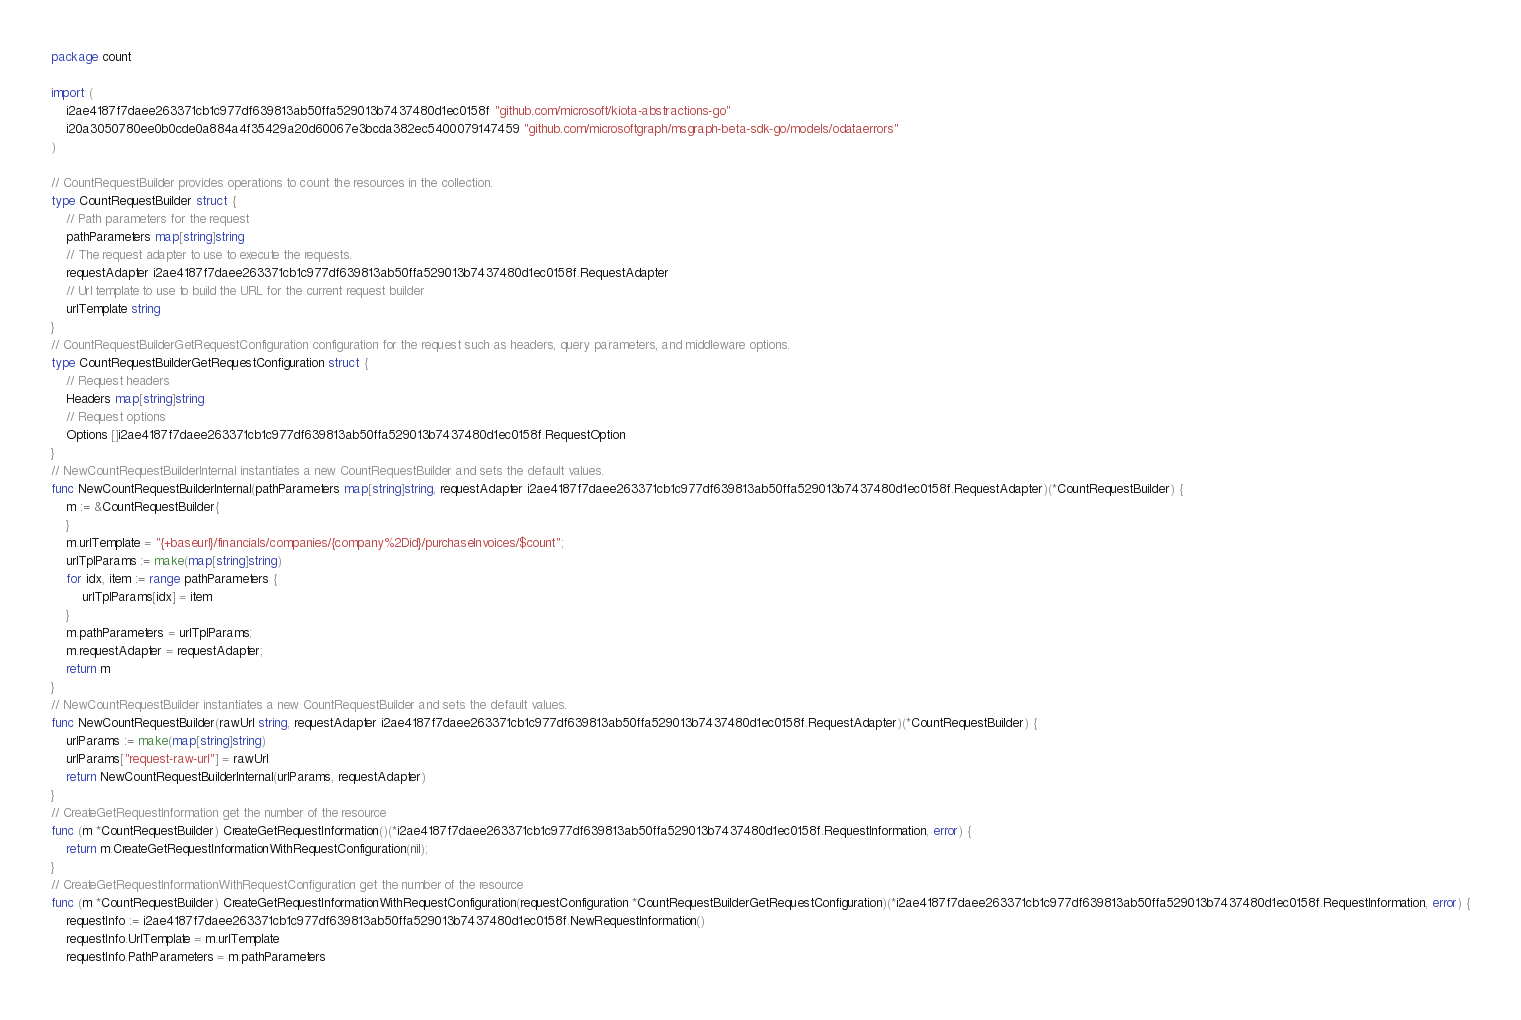<code> <loc_0><loc_0><loc_500><loc_500><_Go_>package count

import (
    i2ae4187f7daee263371cb1c977df639813ab50ffa529013b7437480d1ec0158f "github.com/microsoft/kiota-abstractions-go"
    i20a3050780ee0b0cde0a884a4f35429a20d60067e3bcda382ec5400079147459 "github.com/microsoftgraph/msgraph-beta-sdk-go/models/odataerrors"
)

// CountRequestBuilder provides operations to count the resources in the collection.
type CountRequestBuilder struct {
    // Path parameters for the request
    pathParameters map[string]string
    // The request adapter to use to execute the requests.
    requestAdapter i2ae4187f7daee263371cb1c977df639813ab50ffa529013b7437480d1ec0158f.RequestAdapter
    // Url template to use to build the URL for the current request builder
    urlTemplate string
}
// CountRequestBuilderGetRequestConfiguration configuration for the request such as headers, query parameters, and middleware options.
type CountRequestBuilderGetRequestConfiguration struct {
    // Request headers
    Headers map[string]string
    // Request options
    Options []i2ae4187f7daee263371cb1c977df639813ab50ffa529013b7437480d1ec0158f.RequestOption
}
// NewCountRequestBuilderInternal instantiates a new CountRequestBuilder and sets the default values.
func NewCountRequestBuilderInternal(pathParameters map[string]string, requestAdapter i2ae4187f7daee263371cb1c977df639813ab50ffa529013b7437480d1ec0158f.RequestAdapter)(*CountRequestBuilder) {
    m := &CountRequestBuilder{
    }
    m.urlTemplate = "{+baseurl}/financials/companies/{company%2Did}/purchaseInvoices/$count";
    urlTplParams := make(map[string]string)
    for idx, item := range pathParameters {
        urlTplParams[idx] = item
    }
    m.pathParameters = urlTplParams;
    m.requestAdapter = requestAdapter;
    return m
}
// NewCountRequestBuilder instantiates a new CountRequestBuilder and sets the default values.
func NewCountRequestBuilder(rawUrl string, requestAdapter i2ae4187f7daee263371cb1c977df639813ab50ffa529013b7437480d1ec0158f.RequestAdapter)(*CountRequestBuilder) {
    urlParams := make(map[string]string)
    urlParams["request-raw-url"] = rawUrl
    return NewCountRequestBuilderInternal(urlParams, requestAdapter)
}
// CreateGetRequestInformation get the number of the resource
func (m *CountRequestBuilder) CreateGetRequestInformation()(*i2ae4187f7daee263371cb1c977df639813ab50ffa529013b7437480d1ec0158f.RequestInformation, error) {
    return m.CreateGetRequestInformationWithRequestConfiguration(nil);
}
// CreateGetRequestInformationWithRequestConfiguration get the number of the resource
func (m *CountRequestBuilder) CreateGetRequestInformationWithRequestConfiguration(requestConfiguration *CountRequestBuilderGetRequestConfiguration)(*i2ae4187f7daee263371cb1c977df639813ab50ffa529013b7437480d1ec0158f.RequestInformation, error) {
    requestInfo := i2ae4187f7daee263371cb1c977df639813ab50ffa529013b7437480d1ec0158f.NewRequestInformation()
    requestInfo.UrlTemplate = m.urlTemplate
    requestInfo.PathParameters = m.pathParameters</code> 